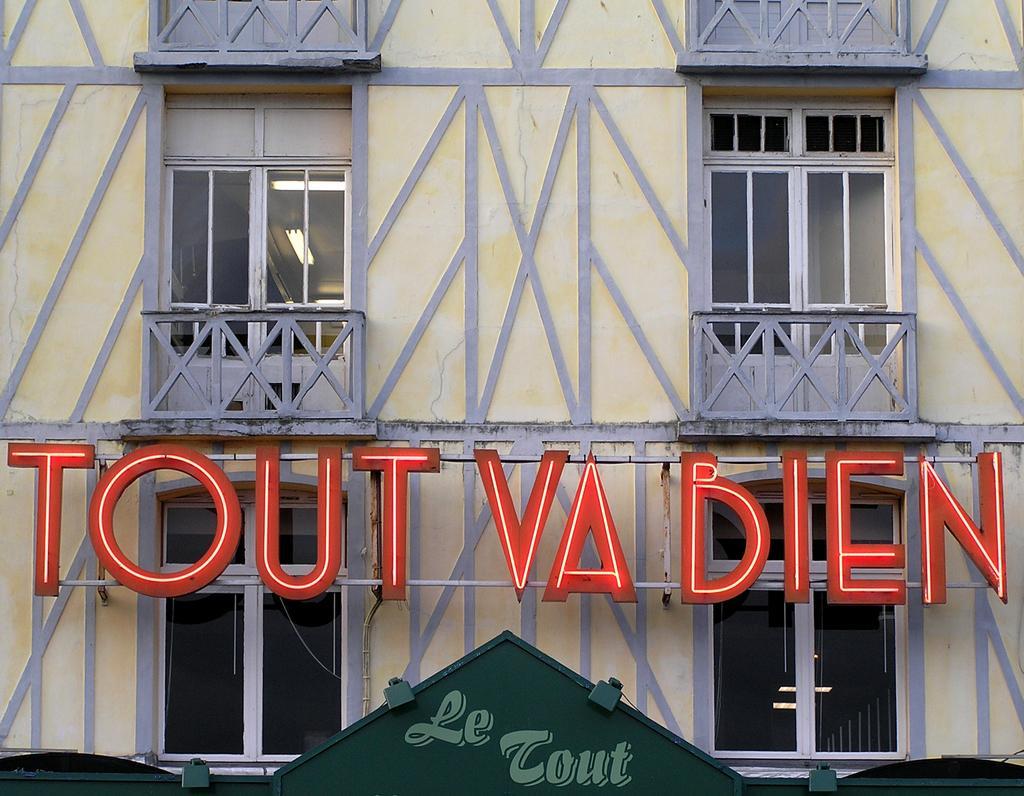Describe this image in one or two sentences. Here in this picture we can see a building with number of windows present over a place and we can see lights present on the roof and in the front we can see a hoarding present. 